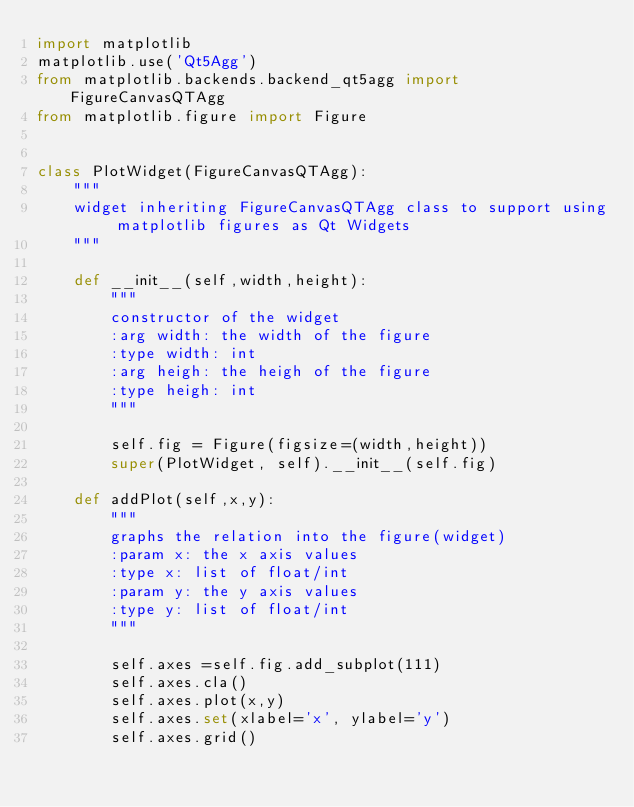Convert code to text. <code><loc_0><loc_0><loc_500><loc_500><_Python_>import matplotlib
matplotlib.use('Qt5Agg')
from matplotlib.backends.backend_qt5agg import FigureCanvasQTAgg
from matplotlib.figure import Figure


class PlotWidget(FigureCanvasQTAgg):
    """
    widget inheriting FigureCanvasQTAgg class to support using matplotlib figures as Qt Widgets
    """

    def __init__(self,width,height):
        """
        constructor of the widget
        :arg width: the width of the figure
        :type width: int
        :arg heigh: the heigh of the figure
        :type heigh: int
        """

        self.fig = Figure(figsize=(width,height))
        super(PlotWidget, self).__init__(self.fig)

    def addPlot(self,x,y):
        """
        graphs the relation into the figure(widget)
        :param x: the x axis values
        :type x: list of float/int
        :param y: the y axis values
        :type y: list of float/int
        """

        self.axes =self.fig.add_subplot(111)
        self.axes.cla()
        self.axes.plot(x,y)
        self.axes.set(xlabel='x', ylabel='y')
        self.axes.grid()




</code> 